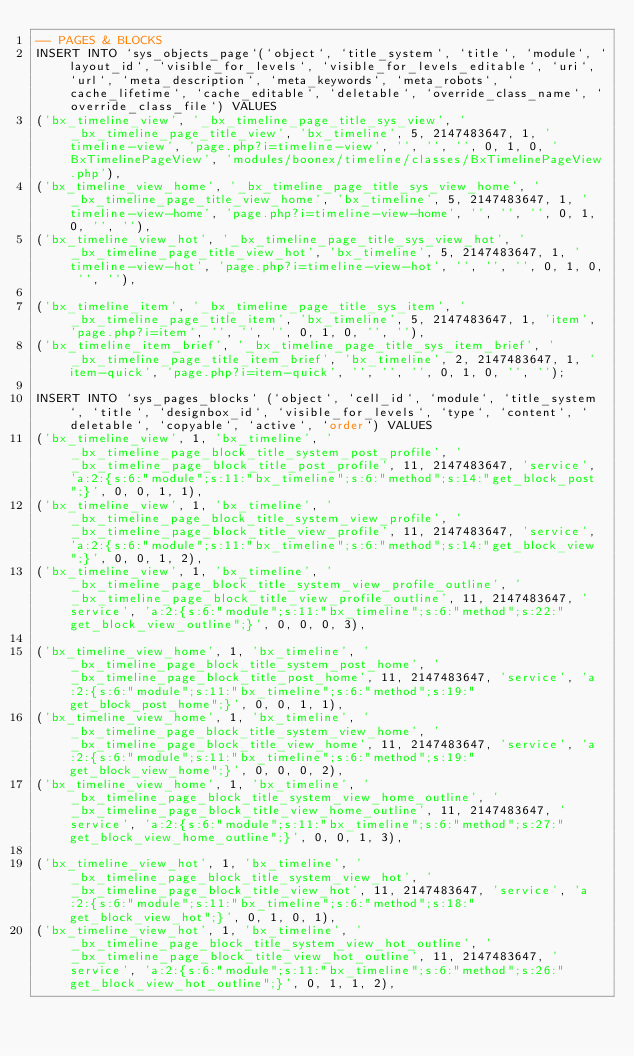Convert code to text. <code><loc_0><loc_0><loc_500><loc_500><_SQL_>-- PAGES & BLOCKS
INSERT INTO `sys_objects_page`(`object`, `title_system`, `title`, `module`, `layout_id`, `visible_for_levels`, `visible_for_levels_editable`, `uri`, `url`, `meta_description`, `meta_keywords`, `meta_robots`, `cache_lifetime`, `cache_editable`, `deletable`, `override_class_name`, `override_class_file`) VALUES 
('bx_timeline_view', '_bx_timeline_page_title_sys_view', '_bx_timeline_page_title_view', 'bx_timeline', 5, 2147483647, 1, 'timeline-view', 'page.php?i=timeline-view', '', '', '', 0, 1, 0, 'BxTimelinePageView', 'modules/boonex/timeline/classes/BxTimelinePageView.php'),
('bx_timeline_view_home', '_bx_timeline_page_title_sys_view_home', '_bx_timeline_page_title_view_home', 'bx_timeline', 5, 2147483647, 1, 'timeline-view-home', 'page.php?i=timeline-view-home', '', '', '', 0, 1, 0, '', ''),
('bx_timeline_view_hot', '_bx_timeline_page_title_sys_view_hot', '_bx_timeline_page_title_view_hot', 'bx_timeline', 5, 2147483647, 1, 'timeline-view-hot', 'page.php?i=timeline-view-hot', '', '', '', 0, 1, 0, '', ''),

('bx_timeline_item', '_bx_timeline_page_title_sys_item', '_bx_timeline_page_title_item', 'bx_timeline', 5, 2147483647, 1, 'item', 'page.php?i=item', '', '', '', 0, 1, 0, '', ''),
('bx_timeline_item_brief', '_bx_timeline_page_title_sys_item_brief', '_bx_timeline_page_title_item_brief', 'bx_timeline', 2, 2147483647, 1, 'item-quick', 'page.php?i=item-quick', '', '', '', 0, 1, 0, '', '');

INSERT INTO `sys_pages_blocks` (`object`, `cell_id`, `module`, `title_system`, `title`, `designbox_id`, `visible_for_levels`, `type`, `content`, `deletable`, `copyable`, `active`, `order`) VALUES
('bx_timeline_view', 1, 'bx_timeline', '_bx_timeline_page_block_title_system_post_profile', '_bx_timeline_page_block_title_post_profile', 11, 2147483647, 'service', 'a:2:{s:6:"module";s:11:"bx_timeline";s:6:"method";s:14:"get_block_post";}', 0, 0, 1, 1),
('bx_timeline_view', 1, 'bx_timeline', '_bx_timeline_page_block_title_system_view_profile', '_bx_timeline_page_block_title_view_profile', 11, 2147483647, 'service', 'a:2:{s:6:"module";s:11:"bx_timeline";s:6:"method";s:14:"get_block_view";}', 0, 0, 1, 2),
('bx_timeline_view', 1, 'bx_timeline', '_bx_timeline_page_block_title_system_view_profile_outline', '_bx_timeline_page_block_title_view_profile_outline', 11, 2147483647, 'service', 'a:2:{s:6:"module";s:11:"bx_timeline";s:6:"method";s:22:"get_block_view_outline";}', 0, 0, 0, 3),

('bx_timeline_view_home', 1, 'bx_timeline', '_bx_timeline_page_block_title_system_post_home', '_bx_timeline_page_block_title_post_home', 11, 2147483647, 'service', 'a:2:{s:6:"module";s:11:"bx_timeline";s:6:"method";s:19:"get_block_post_home";}', 0, 0, 1, 1),
('bx_timeline_view_home', 1, 'bx_timeline', '_bx_timeline_page_block_title_system_view_home', '_bx_timeline_page_block_title_view_home', 11, 2147483647, 'service', 'a:2:{s:6:"module";s:11:"bx_timeline";s:6:"method";s:19:"get_block_view_home";}', 0, 0, 0, 2),
('bx_timeline_view_home', 1, 'bx_timeline', '_bx_timeline_page_block_title_system_view_home_outline', '_bx_timeline_page_block_title_view_home_outline', 11, 2147483647, 'service', 'a:2:{s:6:"module";s:11:"bx_timeline";s:6:"method";s:27:"get_block_view_home_outline";}', 0, 0, 1, 3),

('bx_timeline_view_hot', 1, 'bx_timeline', '_bx_timeline_page_block_title_system_view_hot', '_bx_timeline_page_block_title_view_hot', 11, 2147483647, 'service', 'a:2:{s:6:"module";s:11:"bx_timeline";s:6:"method";s:18:"get_block_view_hot";}', 0, 1, 0, 1),
('bx_timeline_view_hot', 1, 'bx_timeline', '_bx_timeline_page_block_title_system_view_hot_outline', '_bx_timeline_page_block_title_view_hot_outline', 11, 2147483647, 'service', 'a:2:{s:6:"module";s:11:"bx_timeline";s:6:"method";s:26:"get_block_view_hot_outline";}', 0, 1, 1, 2),
</code> 